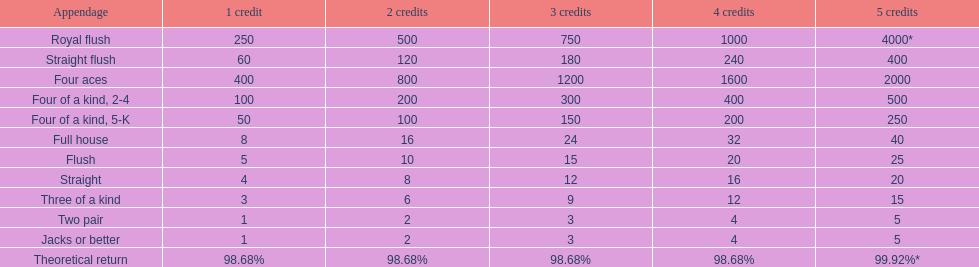Parse the table in full. {'header': ['Appendage', '1 credit', '2 credits', '3 credits', '4 credits', '5 credits'], 'rows': [['Royal flush', '250', '500', '750', '1000', '4000*'], ['Straight flush', '60', '120', '180', '240', '400'], ['Four aces', '400', '800', '1200', '1600', '2000'], ['Four of a kind, 2-4', '100', '200', '300', '400', '500'], ['Four of a kind, 5-K', '50', '100', '150', '200', '250'], ['Full house', '8', '16', '24', '32', '40'], ['Flush', '5', '10', '15', '20', '25'], ['Straight', '4', '8', '12', '16', '20'], ['Three of a kind', '3', '6', '9', '12', '15'], ['Two pair', '1', '2', '3', '4', '5'], ['Jacks or better', '1', '2', '3', '4', '5'], ['Theoretical return', '98.68%', '98.68%', '98.68%', '98.68%', '99.92%*']]} Which is a higher standing hand: a straight or a flush? Flush. 